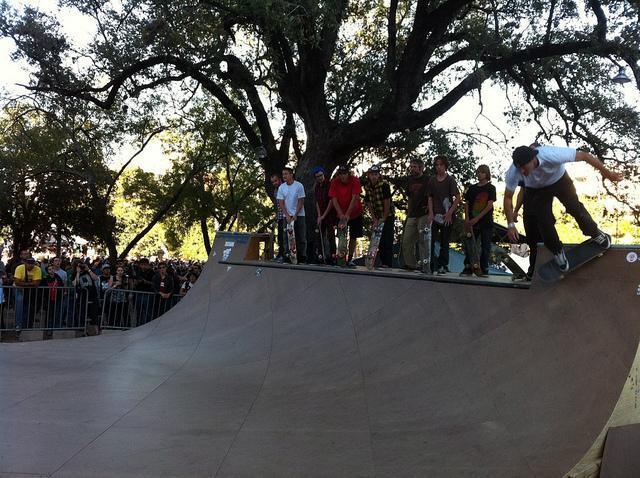How many females are in this picture?
Give a very brief answer. 0. How many people can be seen?
Give a very brief answer. 5. 